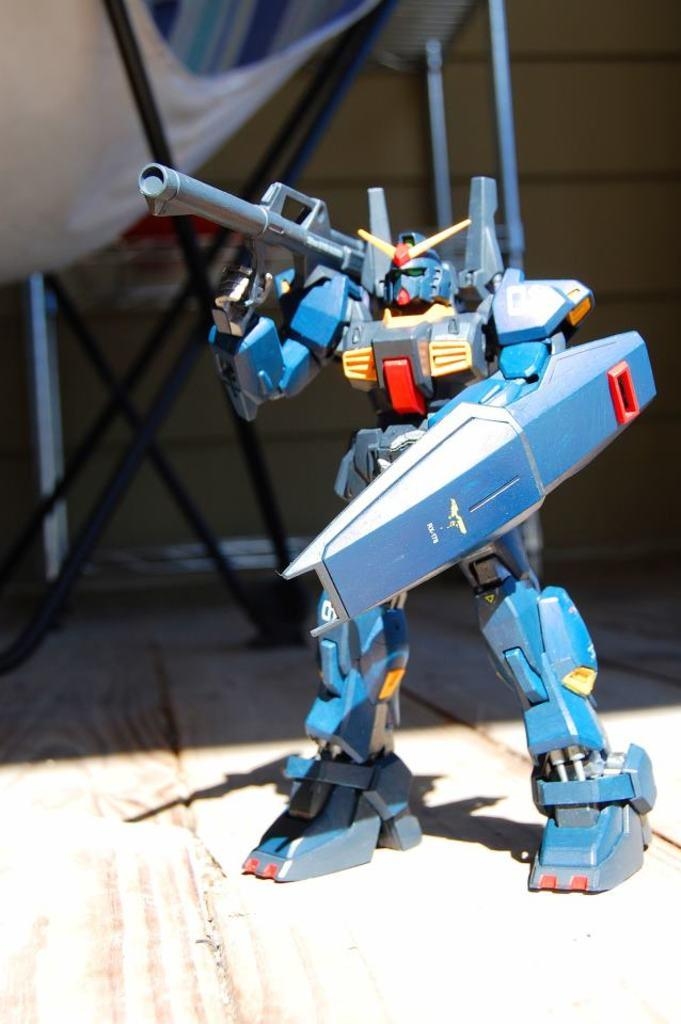What is the main subject in the center of the image? There is a robot in the center of the image. What can be seen in the background of the image? There is a tent in the background of the image. Where is the nearest shop to the robot in the image? There is no shop mentioned or visible in the image. 